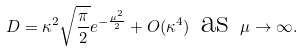Convert formula to latex. <formula><loc_0><loc_0><loc_500><loc_500>D = \kappa ^ { 2 } \sqrt { \frac { \pi } { 2 } } e ^ { - \frac { \mu ^ { 2 } } { 2 } } + O ( \kappa ^ { 4 } ) \text { as } \mu \to \infty .</formula> 